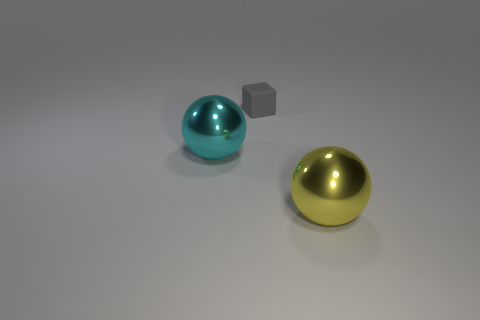Add 1 gray balls. How many objects exist? 4 Subtract all spheres. How many objects are left? 1 Subtract all red blocks. Subtract all blue spheres. How many blocks are left? 1 Subtract all brown cylinders. How many yellow spheres are left? 1 Subtract all blue metal cylinders. Subtract all rubber things. How many objects are left? 2 Add 2 large cyan metal things. How many large cyan metal things are left? 3 Add 2 big blue metal balls. How many big blue metal balls exist? 2 Subtract 0 brown spheres. How many objects are left? 3 Subtract 1 spheres. How many spheres are left? 1 